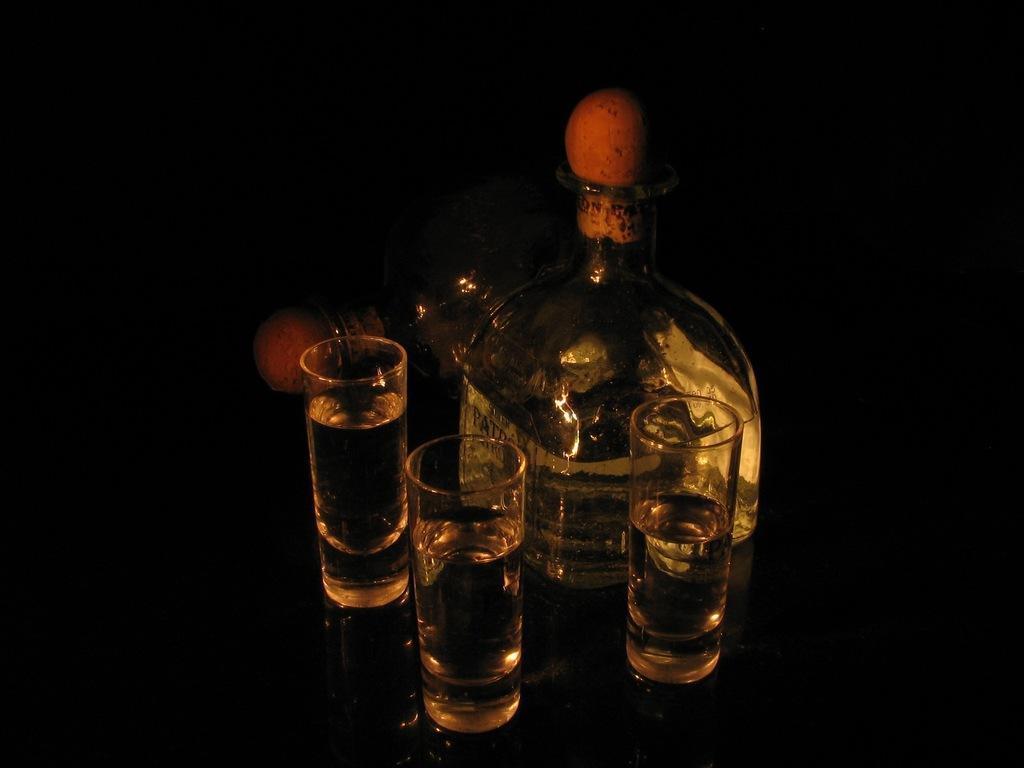Can you describe this image briefly? In this picture on the table there are three glasses and a two glass bottles. Behind the bottle is in black color. 